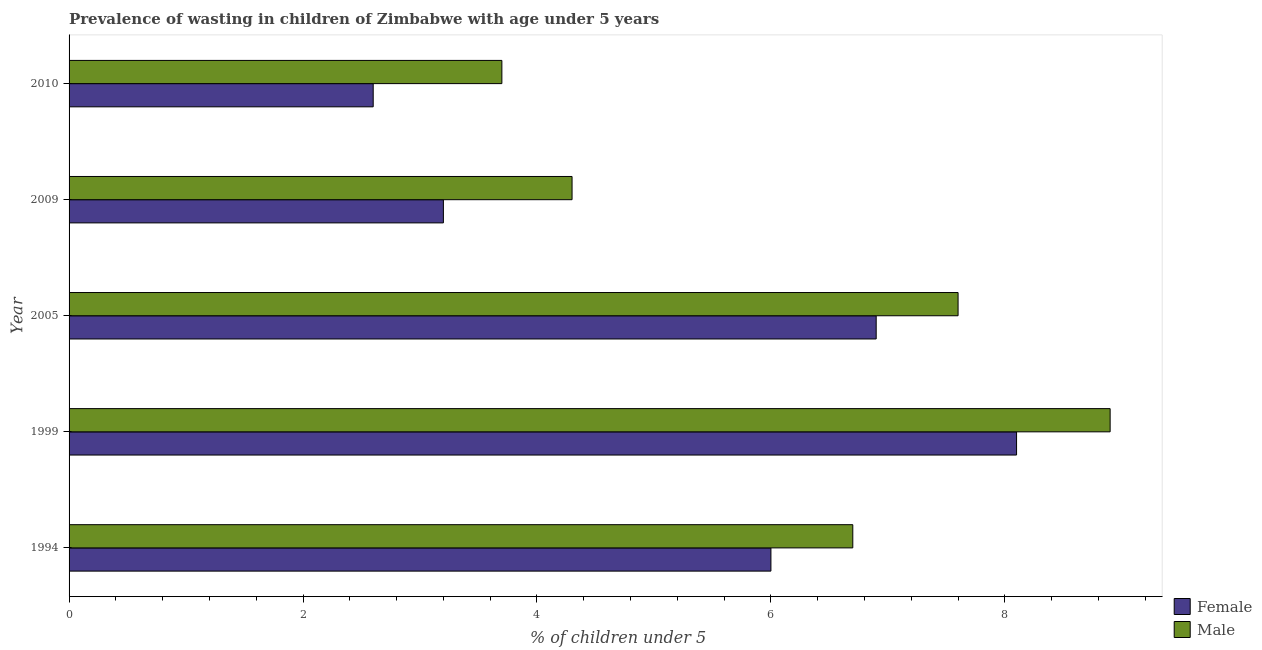How many different coloured bars are there?
Make the answer very short. 2. Are the number of bars per tick equal to the number of legend labels?
Ensure brevity in your answer.  Yes. How many bars are there on the 4th tick from the top?
Ensure brevity in your answer.  2. In how many cases, is the number of bars for a given year not equal to the number of legend labels?
Your response must be concise. 0. What is the percentage of undernourished female children in 2009?
Make the answer very short. 3.2. Across all years, what is the maximum percentage of undernourished male children?
Keep it short and to the point. 8.9. Across all years, what is the minimum percentage of undernourished male children?
Ensure brevity in your answer.  3.7. In which year was the percentage of undernourished female children minimum?
Keep it short and to the point. 2010. What is the total percentage of undernourished female children in the graph?
Offer a terse response. 26.8. What is the difference between the percentage of undernourished male children in 2009 and the percentage of undernourished female children in 1999?
Keep it short and to the point. -3.8. What is the average percentage of undernourished female children per year?
Ensure brevity in your answer.  5.36. In the year 1999, what is the difference between the percentage of undernourished male children and percentage of undernourished female children?
Your answer should be very brief. 0.8. In how many years, is the percentage of undernourished female children greater than 8.8 %?
Your response must be concise. 0. What is the ratio of the percentage of undernourished female children in 1994 to that in 2010?
Provide a short and direct response. 2.31. Is the difference between the percentage of undernourished male children in 2005 and 2009 greater than the difference between the percentage of undernourished female children in 2005 and 2009?
Make the answer very short. No. What is the difference between the highest and the second highest percentage of undernourished female children?
Provide a short and direct response. 1.2. In how many years, is the percentage of undernourished male children greater than the average percentage of undernourished male children taken over all years?
Offer a terse response. 3. Is the sum of the percentage of undernourished female children in 1994 and 1999 greater than the maximum percentage of undernourished male children across all years?
Offer a very short reply. Yes. What does the 1st bar from the bottom in 2009 represents?
Your answer should be compact. Female. Are the values on the major ticks of X-axis written in scientific E-notation?
Provide a short and direct response. No. Does the graph contain grids?
Ensure brevity in your answer.  No. Where does the legend appear in the graph?
Your response must be concise. Bottom right. How are the legend labels stacked?
Provide a short and direct response. Vertical. What is the title of the graph?
Your answer should be very brief. Prevalence of wasting in children of Zimbabwe with age under 5 years. Does "Highest 10% of population" appear as one of the legend labels in the graph?
Ensure brevity in your answer.  No. What is the label or title of the X-axis?
Provide a short and direct response.  % of children under 5. What is the label or title of the Y-axis?
Your answer should be very brief. Year. What is the  % of children under 5 of Male in 1994?
Give a very brief answer. 6.7. What is the  % of children under 5 of Female in 1999?
Offer a very short reply. 8.1. What is the  % of children under 5 of Male in 1999?
Provide a short and direct response. 8.9. What is the  % of children under 5 of Female in 2005?
Offer a terse response. 6.9. What is the  % of children under 5 in Male in 2005?
Keep it short and to the point. 7.6. What is the  % of children under 5 in Female in 2009?
Your answer should be very brief. 3.2. What is the  % of children under 5 in Male in 2009?
Offer a very short reply. 4.3. What is the  % of children under 5 in Female in 2010?
Your answer should be compact. 2.6. What is the  % of children under 5 in Male in 2010?
Offer a very short reply. 3.7. Across all years, what is the maximum  % of children under 5 of Female?
Give a very brief answer. 8.1. Across all years, what is the maximum  % of children under 5 in Male?
Offer a terse response. 8.9. Across all years, what is the minimum  % of children under 5 in Female?
Provide a short and direct response. 2.6. Across all years, what is the minimum  % of children under 5 in Male?
Your answer should be very brief. 3.7. What is the total  % of children under 5 in Female in the graph?
Give a very brief answer. 26.8. What is the total  % of children under 5 of Male in the graph?
Keep it short and to the point. 31.2. What is the difference between the  % of children under 5 of Female in 1994 and that in 1999?
Give a very brief answer. -2.1. What is the difference between the  % of children under 5 of Female in 1994 and that in 2005?
Keep it short and to the point. -0.9. What is the difference between the  % of children under 5 of Male in 1994 and that in 2005?
Make the answer very short. -0.9. What is the difference between the  % of children under 5 of Female in 1994 and that in 2009?
Offer a terse response. 2.8. What is the difference between the  % of children under 5 in Male in 1994 and that in 2009?
Ensure brevity in your answer.  2.4. What is the difference between the  % of children under 5 in Female in 1994 and that in 2010?
Your answer should be compact. 3.4. What is the difference between the  % of children under 5 of Male in 1994 and that in 2010?
Your answer should be very brief. 3. What is the difference between the  % of children under 5 in Female in 1999 and that in 2005?
Offer a terse response. 1.2. What is the difference between the  % of children under 5 of Female in 1999 and that in 2009?
Your answer should be compact. 4.9. What is the difference between the  % of children under 5 of Female in 1999 and that in 2010?
Make the answer very short. 5.5. What is the difference between the  % of children under 5 in Male in 2005 and that in 2010?
Provide a short and direct response. 3.9. What is the difference between the  % of children under 5 of Female in 2009 and that in 2010?
Give a very brief answer. 0.6. What is the difference between the  % of children under 5 in Female in 1994 and the  % of children under 5 in Male in 1999?
Your response must be concise. -2.9. What is the difference between the  % of children under 5 of Female in 1994 and the  % of children under 5 of Male in 2009?
Provide a short and direct response. 1.7. What is the difference between the  % of children under 5 of Female in 1994 and the  % of children under 5 of Male in 2010?
Keep it short and to the point. 2.3. What is the difference between the  % of children under 5 of Female in 1999 and the  % of children under 5 of Male in 2005?
Offer a terse response. 0.5. What is the difference between the  % of children under 5 in Female in 2005 and the  % of children under 5 in Male in 2009?
Ensure brevity in your answer.  2.6. What is the average  % of children under 5 in Female per year?
Keep it short and to the point. 5.36. What is the average  % of children under 5 of Male per year?
Your answer should be compact. 6.24. In the year 1999, what is the difference between the  % of children under 5 of Female and  % of children under 5 of Male?
Offer a very short reply. -0.8. In the year 2009, what is the difference between the  % of children under 5 in Female and  % of children under 5 in Male?
Your answer should be very brief. -1.1. What is the ratio of the  % of children under 5 of Female in 1994 to that in 1999?
Your answer should be very brief. 0.74. What is the ratio of the  % of children under 5 of Male in 1994 to that in 1999?
Your response must be concise. 0.75. What is the ratio of the  % of children under 5 of Female in 1994 to that in 2005?
Give a very brief answer. 0.87. What is the ratio of the  % of children under 5 of Male in 1994 to that in 2005?
Keep it short and to the point. 0.88. What is the ratio of the  % of children under 5 of Female in 1994 to that in 2009?
Keep it short and to the point. 1.88. What is the ratio of the  % of children under 5 in Male in 1994 to that in 2009?
Offer a very short reply. 1.56. What is the ratio of the  % of children under 5 of Female in 1994 to that in 2010?
Make the answer very short. 2.31. What is the ratio of the  % of children under 5 in Male in 1994 to that in 2010?
Your response must be concise. 1.81. What is the ratio of the  % of children under 5 of Female in 1999 to that in 2005?
Offer a very short reply. 1.17. What is the ratio of the  % of children under 5 of Male in 1999 to that in 2005?
Your answer should be compact. 1.17. What is the ratio of the  % of children under 5 of Female in 1999 to that in 2009?
Make the answer very short. 2.53. What is the ratio of the  % of children under 5 of Male in 1999 to that in 2009?
Ensure brevity in your answer.  2.07. What is the ratio of the  % of children under 5 in Female in 1999 to that in 2010?
Give a very brief answer. 3.12. What is the ratio of the  % of children under 5 of Male in 1999 to that in 2010?
Make the answer very short. 2.41. What is the ratio of the  % of children under 5 in Female in 2005 to that in 2009?
Keep it short and to the point. 2.16. What is the ratio of the  % of children under 5 in Male in 2005 to that in 2009?
Your response must be concise. 1.77. What is the ratio of the  % of children under 5 of Female in 2005 to that in 2010?
Your response must be concise. 2.65. What is the ratio of the  % of children under 5 in Male in 2005 to that in 2010?
Ensure brevity in your answer.  2.05. What is the ratio of the  % of children under 5 of Female in 2009 to that in 2010?
Your answer should be very brief. 1.23. What is the ratio of the  % of children under 5 in Male in 2009 to that in 2010?
Provide a short and direct response. 1.16. What is the difference between the highest and the second highest  % of children under 5 of Female?
Your answer should be compact. 1.2. 